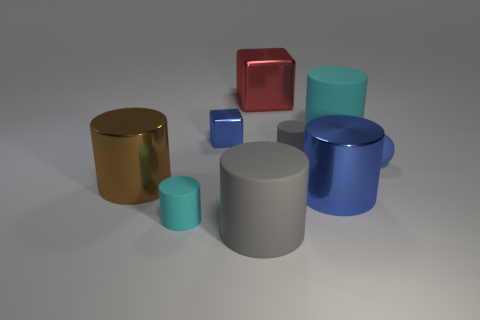Subtract 2 cylinders. How many cylinders are left? 4 Subtract all blue cylinders. How many cylinders are left? 5 Subtract all large blue shiny cylinders. How many cylinders are left? 5 Subtract all purple cylinders. Subtract all purple balls. How many cylinders are left? 6 Add 1 tiny matte objects. How many objects exist? 10 Subtract all cubes. How many objects are left? 7 Add 1 tiny gray rubber cylinders. How many tiny gray rubber cylinders are left? 2 Add 1 tiny purple metal cylinders. How many tiny purple metal cylinders exist? 1 Subtract 0 gray balls. How many objects are left? 9 Subtract all red rubber things. Subtract all cyan matte cylinders. How many objects are left? 7 